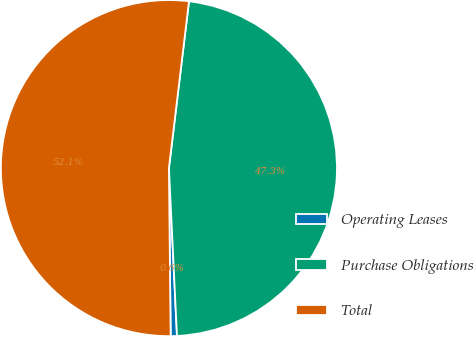Convert chart to OTSL. <chart><loc_0><loc_0><loc_500><loc_500><pie_chart><fcel>Operating Leases<fcel>Purchase Obligations<fcel>Total<nl><fcel>0.6%<fcel>47.33%<fcel>52.07%<nl></chart> 